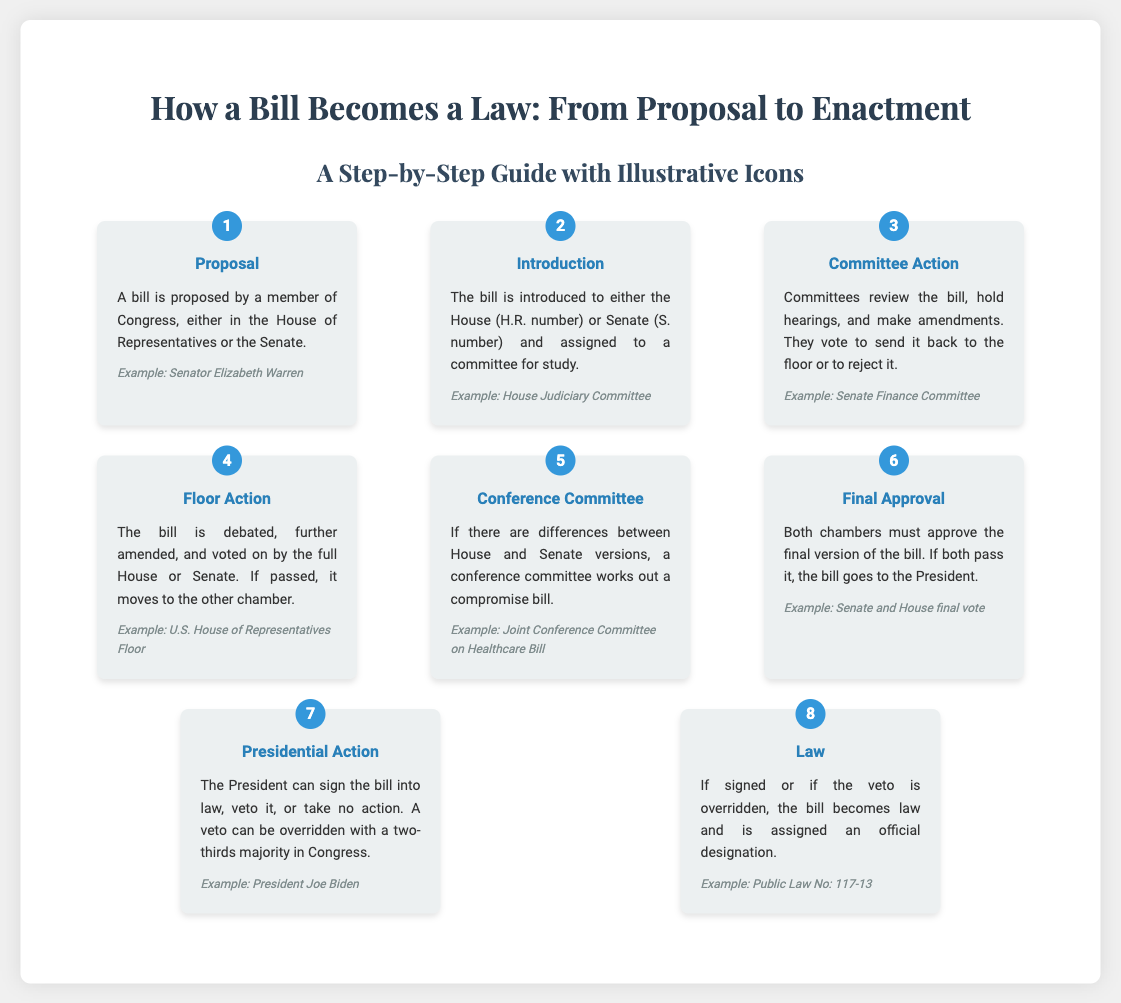What is the first step in the process of a bill becoming a law? The first step listed in the infographic is Proposal, where a bill is proposed by a member of Congress.
Answer: Proposal Which committee might a bill be assigned to after introduction in the House? The example given for a committee assignment after introduction is the House Judiciary Committee.
Answer: House Judiciary Committee What is the role of the Conference Committee? The Conference Committee works out a compromise bill if there are differences between House and Senate versions.
Answer: Compromise bill How many steps are outlined in the infographic? There are eight steps outlined in the process of how a bill becomes a law.
Answer: Eight What action can the President take regarding a bill? The infographic states that the President can sign the bill into law, veto it, or take no action.
Answer: Sign, veto, or no action What example is provided for the Presidential Action step? The example given for Presidential Action is President Joe Biden.
Answer: President Joe Biden What happens if both chambers approve the final version of the bill? If both chambers approve the final version, the bill goes to the President.
Answer: Goes to the President What is assigned to a bill when it becomes law? When a bill becomes law, it is assigned an official designation.
Answer: Official designation 